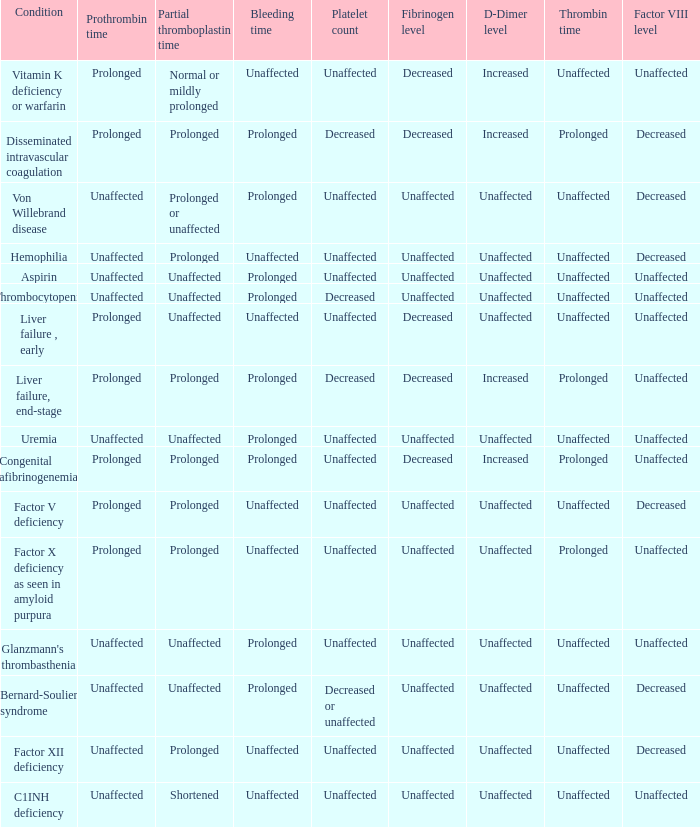Which Condition has an unaffected Prothrombin time and a Bleeding time, and a Partial thromboplastin time of prolonged? Hemophilia, Factor XII deficiency. 